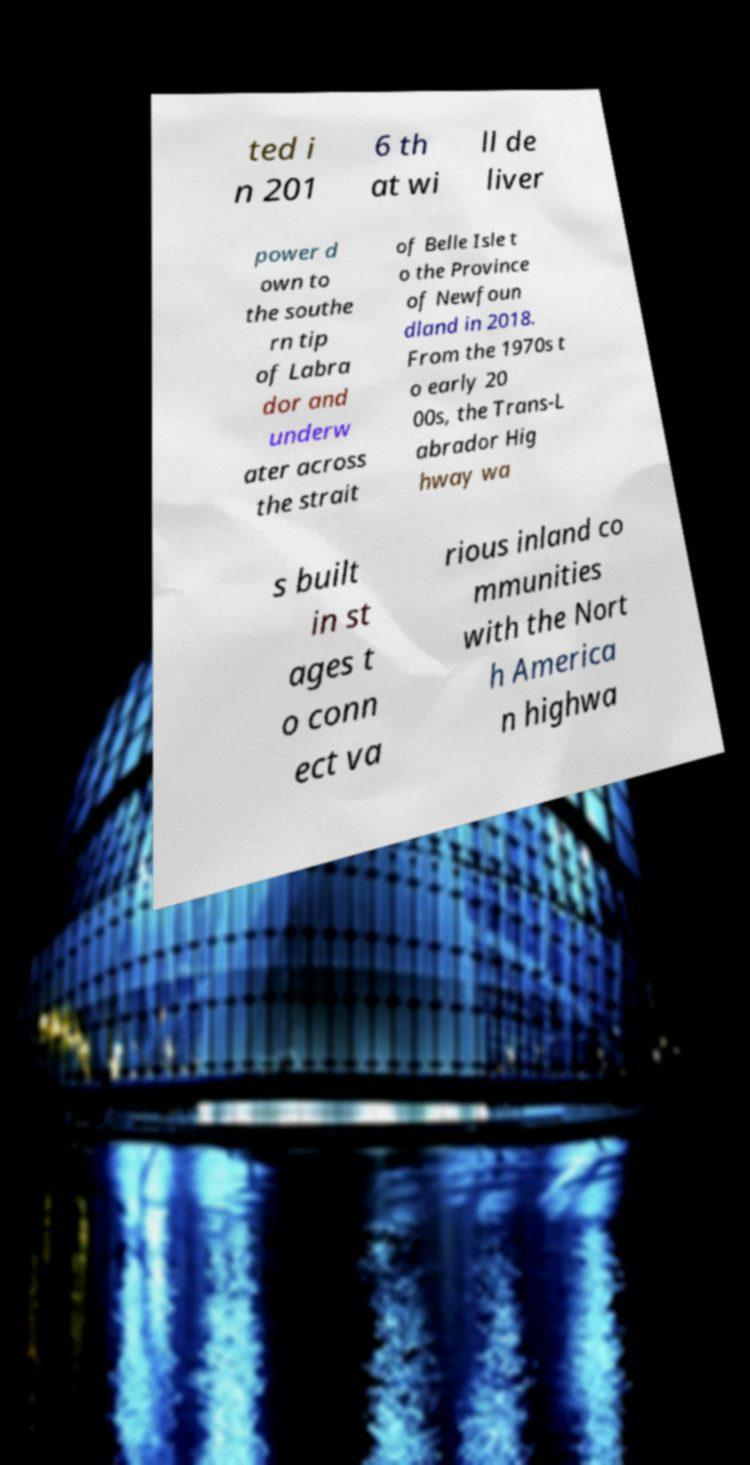I need the written content from this picture converted into text. Can you do that? ted i n 201 6 th at wi ll de liver power d own to the southe rn tip of Labra dor and underw ater across the strait of Belle Isle t o the Province of Newfoun dland in 2018. From the 1970s t o early 20 00s, the Trans-L abrador Hig hway wa s built in st ages t o conn ect va rious inland co mmunities with the Nort h America n highwa 